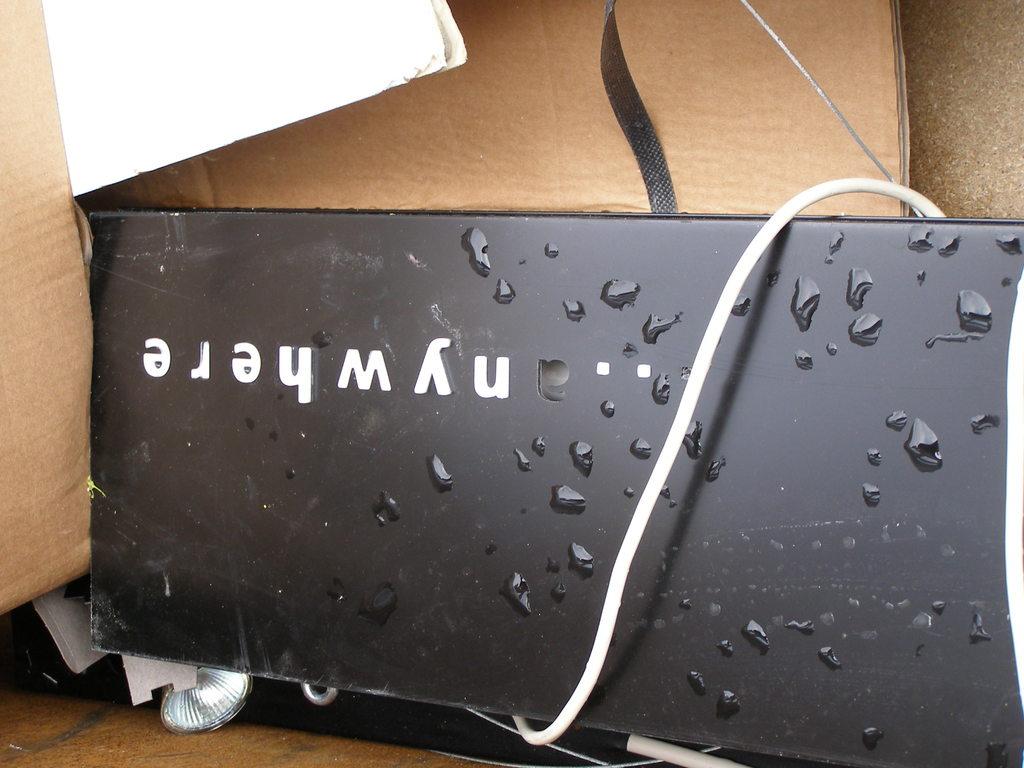What 2 letters come before "where"?
Ensure brevity in your answer.  Ny. What does the box say on it?
Your response must be concise. Nywhere. 